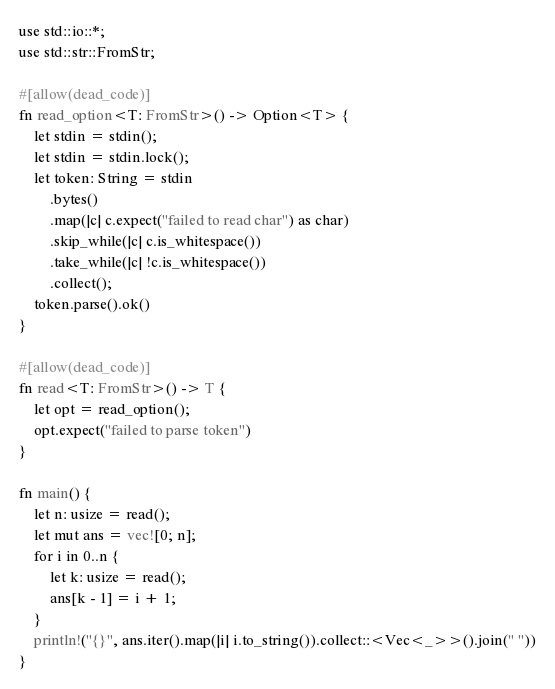<code> <loc_0><loc_0><loc_500><loc_500><_Rust_>use std::io::*;
use std::str::FromStr;

#[allow(dead_code)]
fn read_option<T: FromStr>() -> Option<T> {
    let stdin = stdin();
    let stdin = stdin.lock();
    let token: String = stdin
        .bytes()
        .map(|c| c.expect("failed to read char") as char)
        .skip_while(|c| c.is_whitespace())
        .take_while(|c| !c.is_whitespace())
        .collect();
    token.parse().ok()
}

#[allow(dead_code)]
fn read<T: FromStr>() -> T {
    let opt = read_option();
    opt.expect("failed to parse token")
}

fn main() {
    let n: usize = read();
    let mut ans = vec![0; n];
    for i in 0..n {
        let k: usize = read();
        ans[k - 1] = i + 1;
    }
    println!("{}", ans.iter().map(|i| i.to_string()).collect::<Vec<_>>().join(" "))
}
</code> 